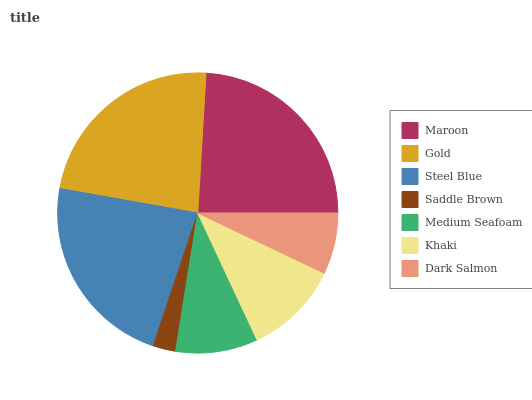Is Saddle Brown the minimum?
Answer yes or no. Yes. Is Maroon the maximum?
Answer yes or no. Yes. Is Gold the minimum?
Answer yes or no. No. Is Gold the maximum?
Answer yes or no. No. Is Maroon greater than Gold?
Answer yes or no. Yes. Is Gold less than Maroon?
Answer yes or no. Yes. Is Gold greater than Maroon?
Answer yes or no. No. Is Maroon less than Gold?
Answer yes or no. No. Is Khaki the high median?
Answer yes or no. Yes. Is Khaki the low median?
Answer yes or no. Yes. Is Saddle Brown the high median?
Answer yes or no. No. Is Saddle Brown the low median?
Answer yes or no. No. 